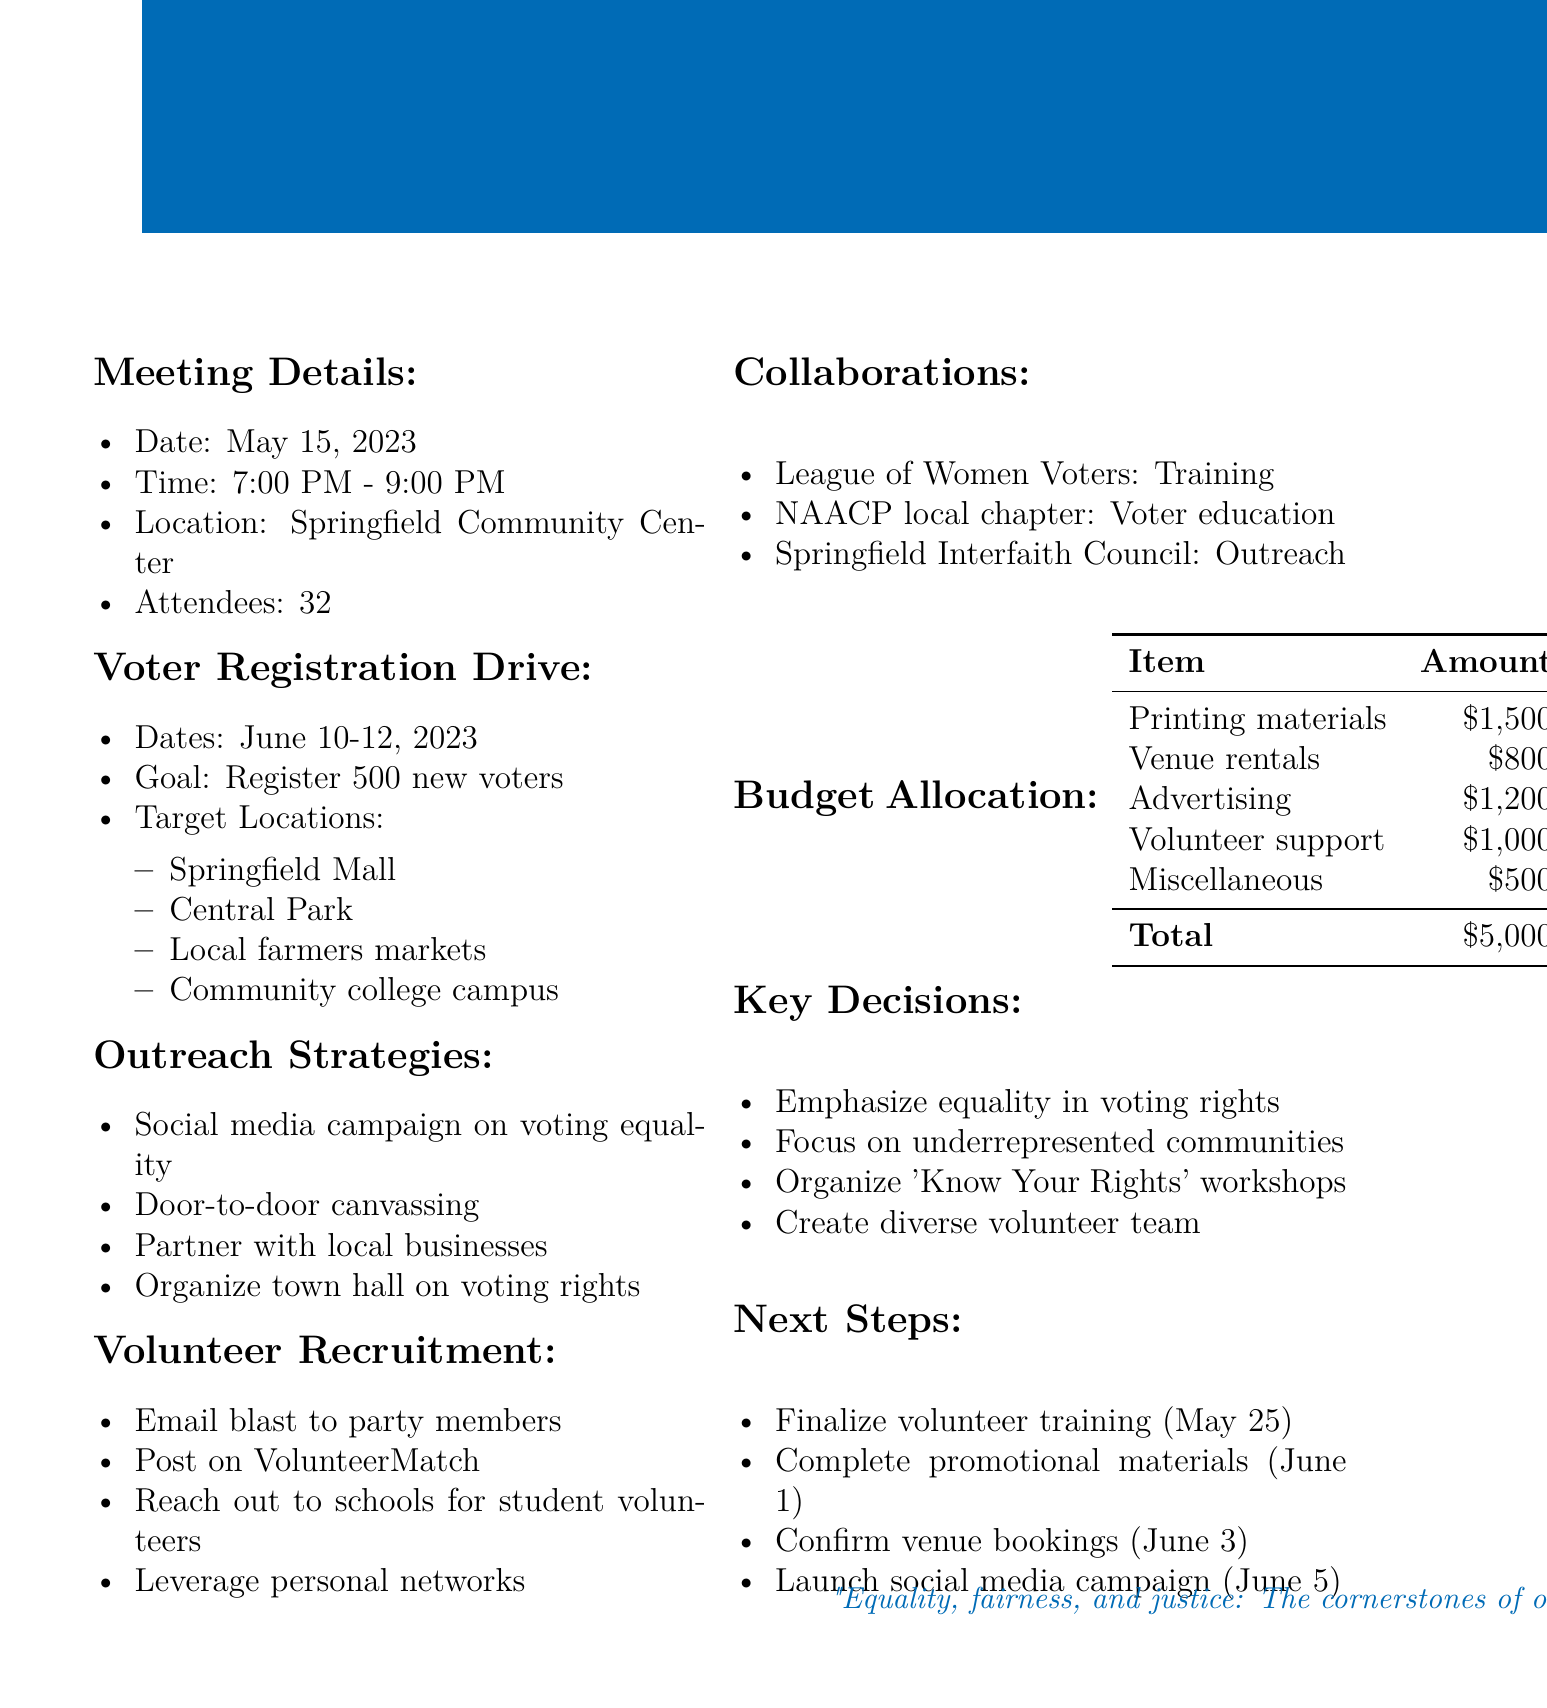What is the date of the meeting? The date of the meeting is listed under "Meeting Details," which states it occurred on May 15, 2023.
Answer: May 15, 2023 What is the goal for the voter registration drive? The goal is outlined in the "Voter Registration Drive" section, specifically stating that the aim is to register 500 new voters.
Answer: Register 500 new voters Which organization is contributing to training volunteers? The document mentions that the League of Women Voters is responsible for training volunteers in the "Collaborations" section.
Answer: League of Women Voters What outreach strategy focuses on voting equality? The document indicates that a social media campaign focusing on equality and fairness in voting is part of the outreach strategies listed.
Answer: Social media campaign How much is allocated for volunteer support in the budget? The budget allocation section includes a specific amount for volunteer support, totaling $1,000.
Answer: $1,000 What is the final date to confirm venue bookings? The "Next Steps" section mentions confirming all venue bookings by June 3.
Answer: June 3 What community will volunteers primarily target during canvassing? The outreach strategies state that door-to-door canvassing will occur in underrepresented neighborhoods, showing an intent to focus on these communities.
Answer: Underrepresented neighborhoods Which local organization is co-hosting voter education workshops? The NAACP local chapter is mentioned in the "Collaborations" section as co-hosting voter education workshops.
Answer: NAACP local chapter 